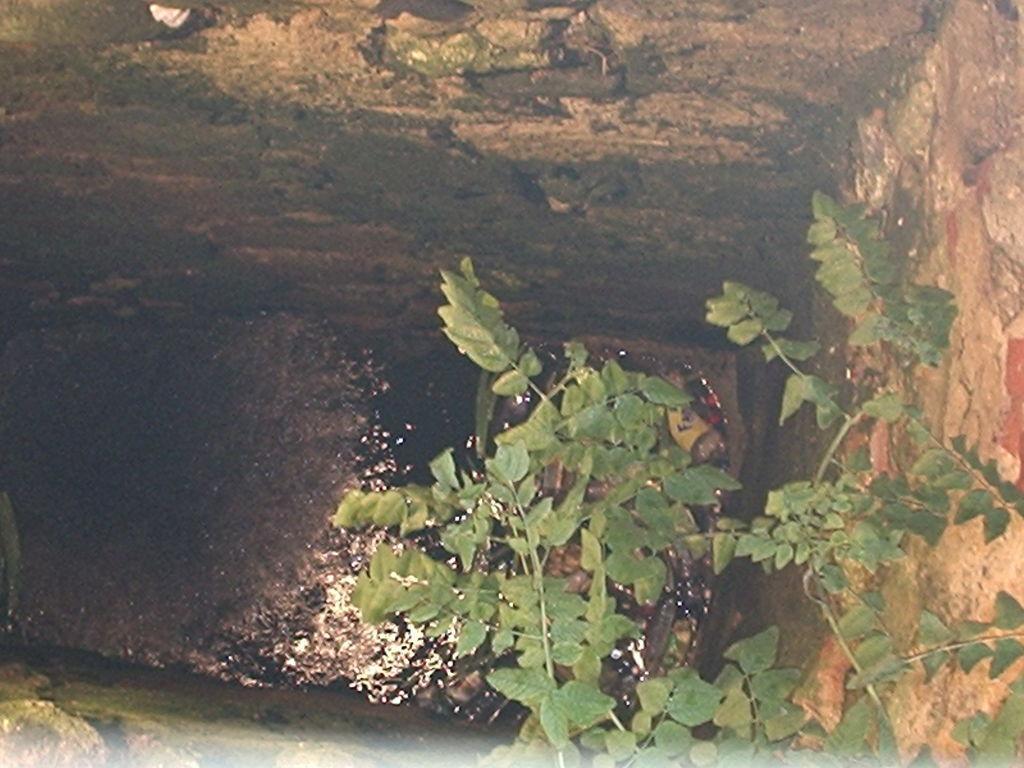Please provide a concise description of this image. In this image I can see the plant and the water. To the side of the water I can see the walls. 